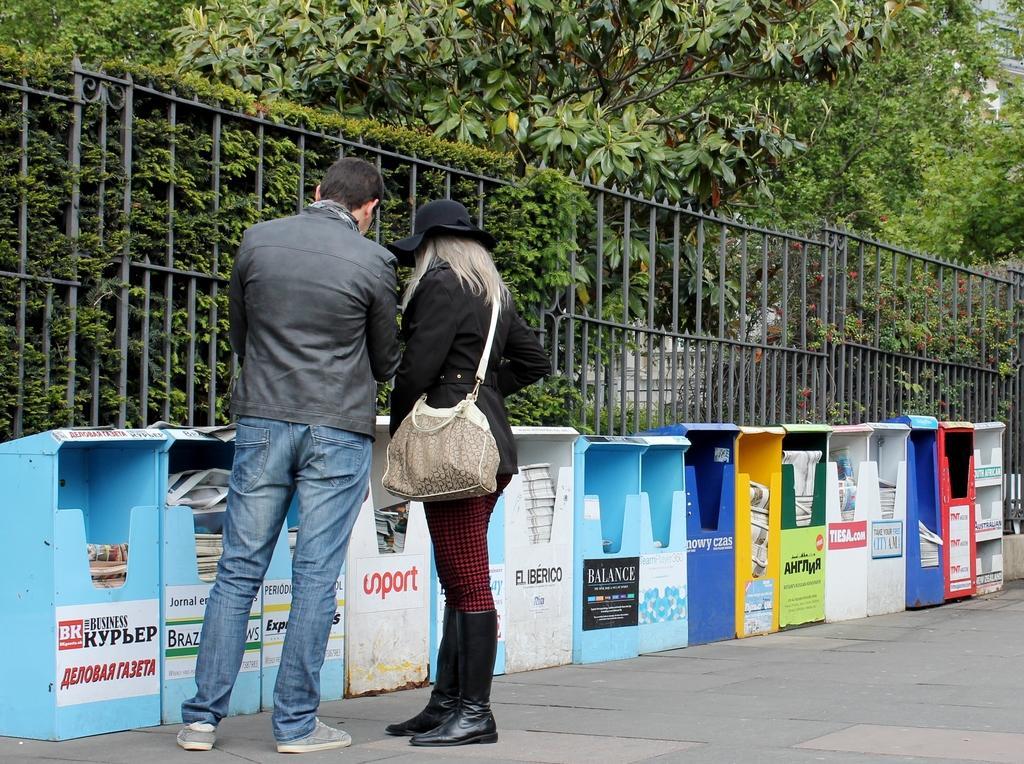How would you summarize this image in a sentence or two? In this picture there is a man and woman stood at side of the road. They are staring at dustbins. Behind the dustbin there is raining and there are several plants,trees in behind. The woman wore black boots and has blond hair with a hand bag. The guy wore grey color jacket. 